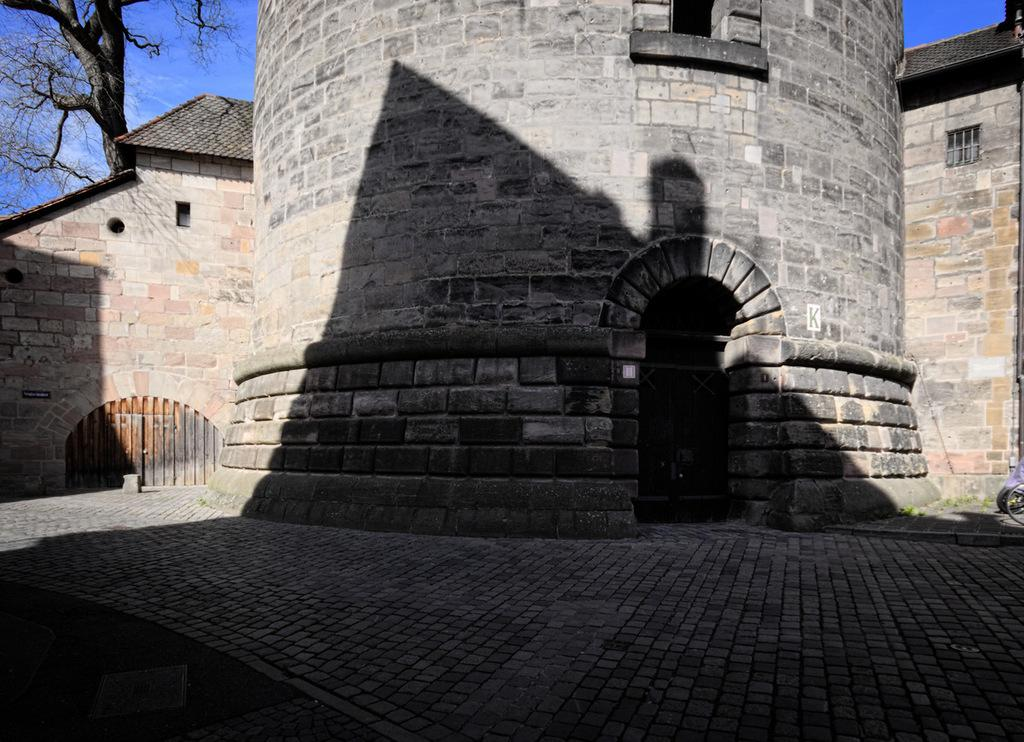What type of structures are present in the image? There are buildings in the image. What architectural features can be seen on the buildings? There are windows and doors visible on the buildings. What is visible in the background of the image? The sky is visible in the image. What type of vegetation is present in the image? There is a tree in the image. What type of medical advice does the doctor give in the image? There is no doctor present in the image, so no medical advice can be given. What is the opinion of the patch on the tree in the image? There is no patch present on the tree in the image, so no opinion can be given. 